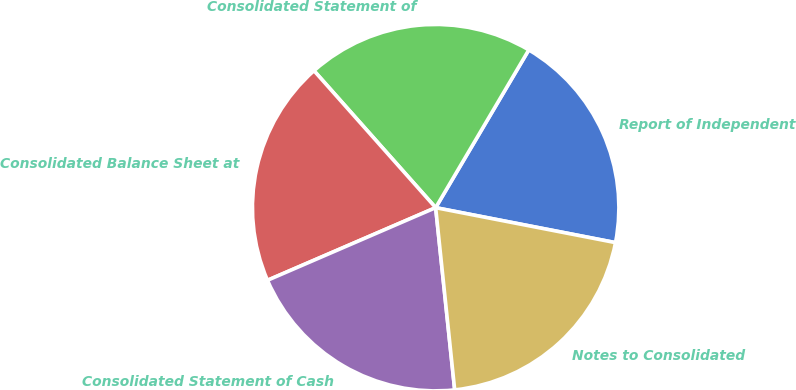Convert chart to OTSL. <chart><loc_0><loc_0><loc_500><loc_500><pie_chart><fcel>Report of Independent<fcel>Consolidated Statement of<fcel>Consolidated Balance Sheet at<fcel>Consolidated Statement of Cash<fcel>Notes to Consolidated<nl><fcel>19.57%<fcel>20.05%<fcel>19.93%<fcel>20.17%<fcel>20.29%<nl></chart> 